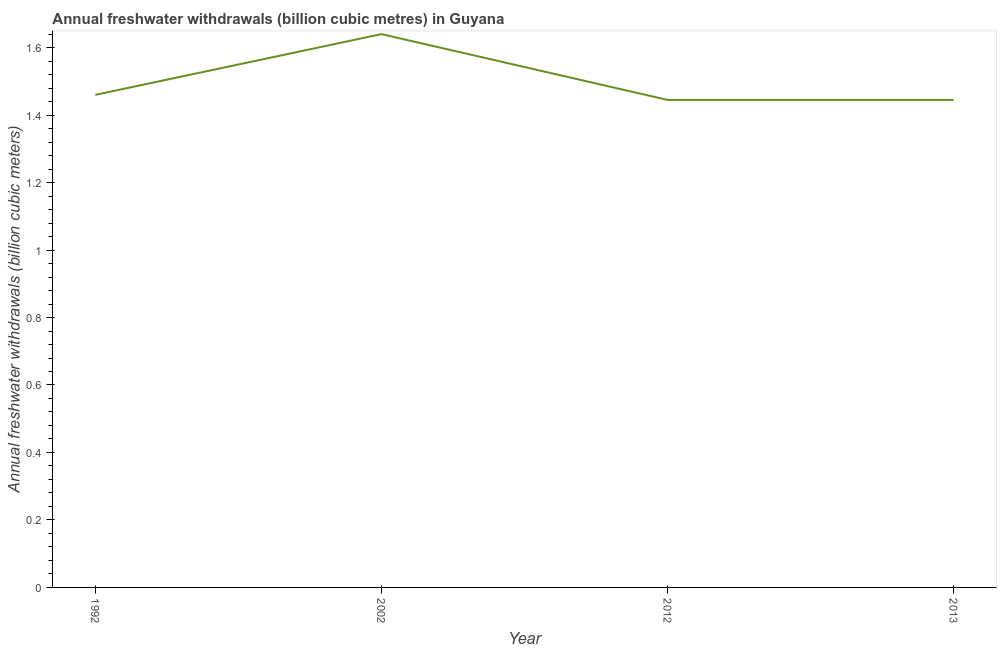What is the annual freshwater withdrawals in 2002?
Provide a short and direct response. 1.64. Across all years, what is the maximum annual freshwater withdrawals?
Offer a very short reply. 1.64. Across all years, what is the minimum annual freshwater withdrawals?
Make the answer very short. 1.45. In which year was the annual freshwater withdrawals maximum?
Your answer should be very brief. 2002. What is the sum of the annual freshwater withdrawals?
Your answer should be very brief. 5.99. What is the difference between the annual freshwater withdrawals in 2002 and 2012?
Give a very brief answer. 0.19. What is the average annual freshwater withdrawals per year?
Ensure brevity in your answer.  1.5. What is the median annual freshwater withdrawals?
Ensure brevity in your answer.  1.45. In how many years, is the annual freshwater withdrawals greater than 0.9600000000000001 billion cubic meters?
Make the answer very short. 4. Do a majority of the years between 2013 and 1992 (inclusive) have annual freshwater withdrawals greater than 0.6400000000000001 billion cubic meters?
Offer a terse response. Yes. What is the ratio of the annual freshwater withdrawals in 2002 to that in 2012?
Offer a terse response. 1.13. Is the annual freshwater withdrawals in 1992 less than that in 2002?
Your response must be concise. Yes. Is the difference between the annual freshwater withdrawals in 2002 and 2012 greater than the difference between any two years?
Provide a short and direct response. Yes. What is the difference between the highest and the second highest annual freshwater withdrawals?
Keep it short and to the point. 0.18. Is the sum of the annual freshwater withdrawals in 2002 and 2013 greater than the maximum annual freshwater withdrawals across all years?
Offer a terse response. Yes. What is the difference between the highest and the lowest annual freshwater withdrawals?
Your answer should be very brief. 0.19. How many lines are there?
Provide a short and direct response. 1. Does the graph contain any zero values?
Offer a terse response. No. Does the graph contain grids?
Offer a very short reply. No. What is the title of the graph?
Offer a very short reply. Annual freshwater withdrawals (billion cubic metres) in Guyana. What is the label or title of the X-axis?
Give a very brief answer. Year. What is the label or title of the Y-axis?
Make the answer very short. Annual freshwater withdrawals (billion cubic meters). What is the Annual freshwater withdrawals (billion cubic meters) in 1992?
Offer a terse response. 1.46. What is the Annual freshwater withdrawals (billion cubic meters) in 2002?
Offer a very short reply. 1.64. What is the Annual freshwater withdrawals (billion cubic meters) in 2012?
Your response must be concise. 1.45. What is the Annual freshwater withdrawals (billion cubic meters) in 2013?
Provide a succinct answer. 1.45. What is the difference between the Annual freshwater withdrawals (billion cubic meters) in 1992 and 2002?
Make the answer very short. -0.18. What is the difference between the Annual freshwater withdrawals (billion cubic meters) in 1992 and 2012?
Keep it short and to the point. 0.01. What is the difference between the Annual freshwater withdrawals (billion cubic meters) in 1992 and 2013?
Give a very brief answer. 0.01. What is the difference between the Annual freshwater withdrawals (billion cubic meters) in 2002 and 2012?
Offer a very short reply. 0.2. What is the difference between the Annual freshwater withdrawals (billion cubic meters) in 2002 and 2013?
Keep it short and to the point. 0.2. What is the difference between the Annual freshwater withdrawals (billion cubic meters) in 2012 and 2013?
Ensure brevity in your answer.  0. What is the ratio of the Annual freshwater withdrawals (billion cubic meters) in 1992 to that in 2002?
Provide a short and direct response. 0.89. What is the ratio of the Annual freshwater withdrawals (billion cubic meters) in 1992 to that in 2013?
Offer a terse response. 1.01. What is the ratio of the Annual freshwater withdrawals (billion cubic meters) in 2002 to that in 2012?
Your response must be concise. 1.14. What is the ratio of the Annual freshwater withdrawals (billion cubic meters) in 2002 to that in 2013?
Your answer should be compact. 1.14. 